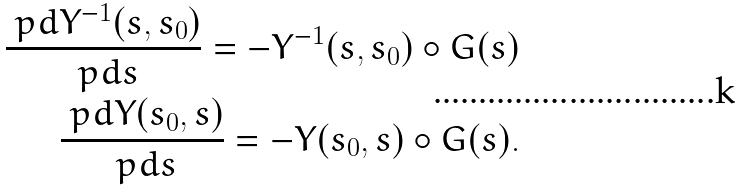Convert formula to latex. <formula><loc_0><loc_0><loc_500><loc_500>\frac { \ p d Y ^ { - 1 } ( s , s _ { 0 } ) } { \ p d s } = - Y ^ { - 1 } ( s , s _ { 0 } ) \circ G ( s ) \\ \frac { \ p d Y ( s _ { 0 } , s ) } { \ p d s } = - Y ( s _ { 0 } , s ) \circ G ( s ) .</formula> 